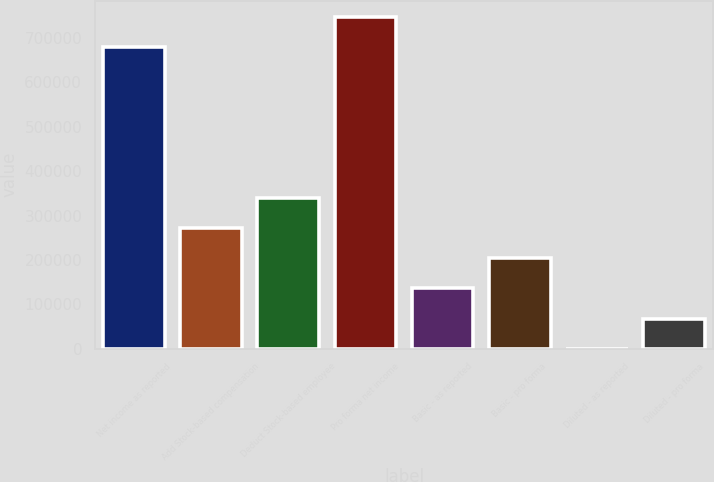<chart> <loc_0><loc_0><loc_500><loc_500><bar_chart><fcel>Net income as reported<fcel>Add Stock-based compensation<fcel>Deduct Stock-based employee<fcel>Pro forma net income<fcel>Basic - as reported<fcel>Basic - pro forma<fcel>Diluted - as reported<fcel>Diluted - pro forma<nl><fcel>678428<fcel>271373<fcel>339216<fcel>746270<fcel>135689<fcel>203531<fcel>3.79<fcel>67846.2<nl></chart> 